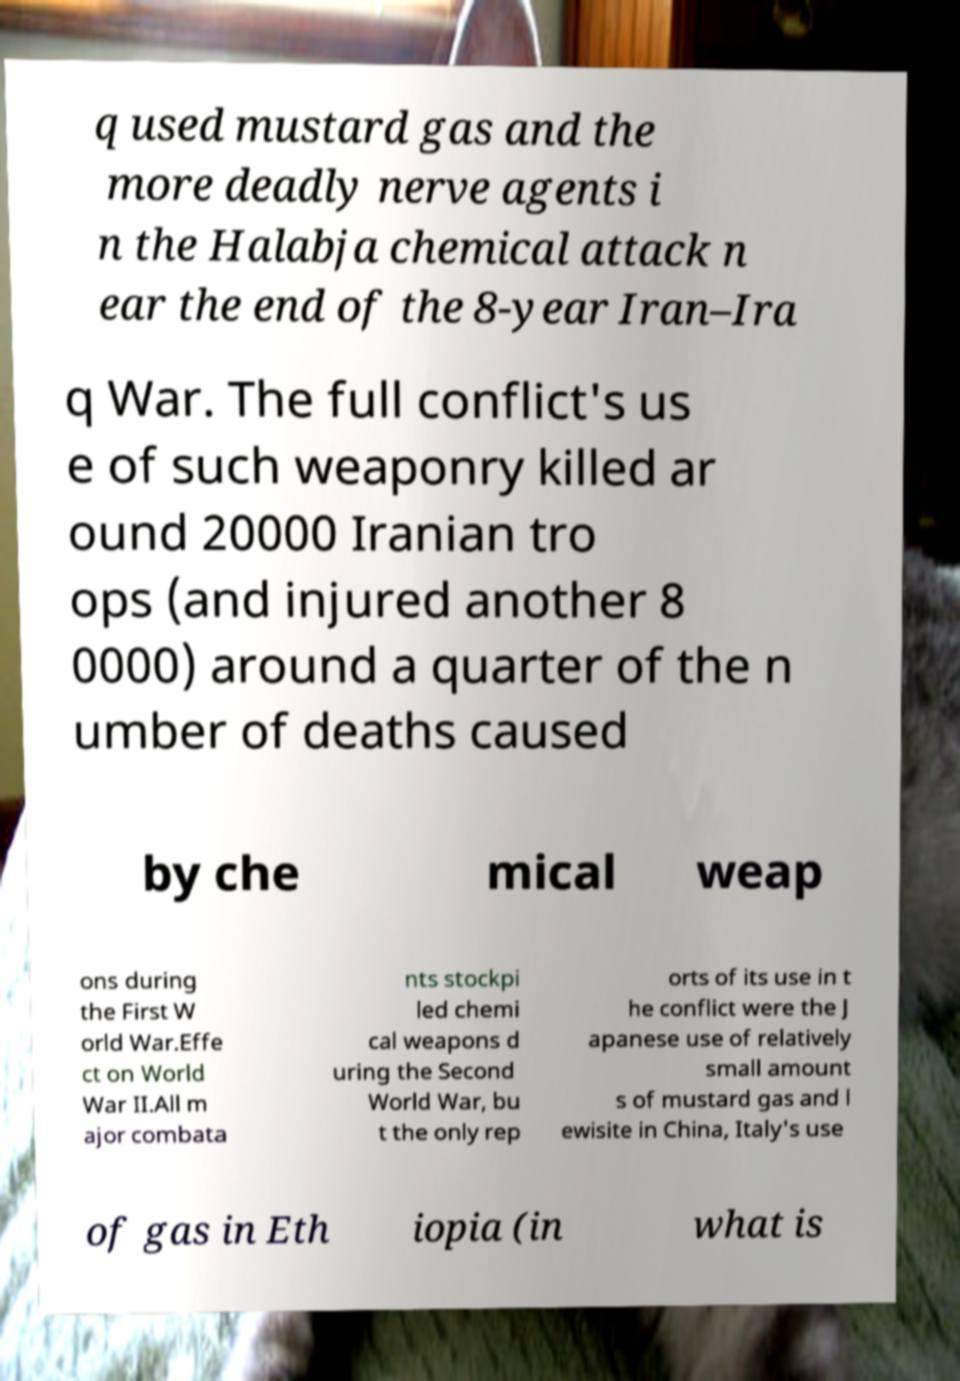There's text embedded in this image that I need extracted. Can you transcribe it verbatim? q used mustard gas and the more deadly nerve agents i n the Halabja chemical attack n ear the end of the 8-year Iran–Ira q War. The full conflict's us e of such weaponry killed ar ound 20000 Iranian tro ops (and injured another 8 0000) around a quarter of the n umber of deaths caused by che mical weap ons during the First W orld War.Effe ct on World War II.All m ajor combata nts stockpi led chemi cal weapons d uring the Second World War, bu t the only rep orts of its use in t he conflict were the J apanese use of relatively small amount s of mustard gas and l ewisite in China, Italy's use of gas in Eth iopia (in what is 